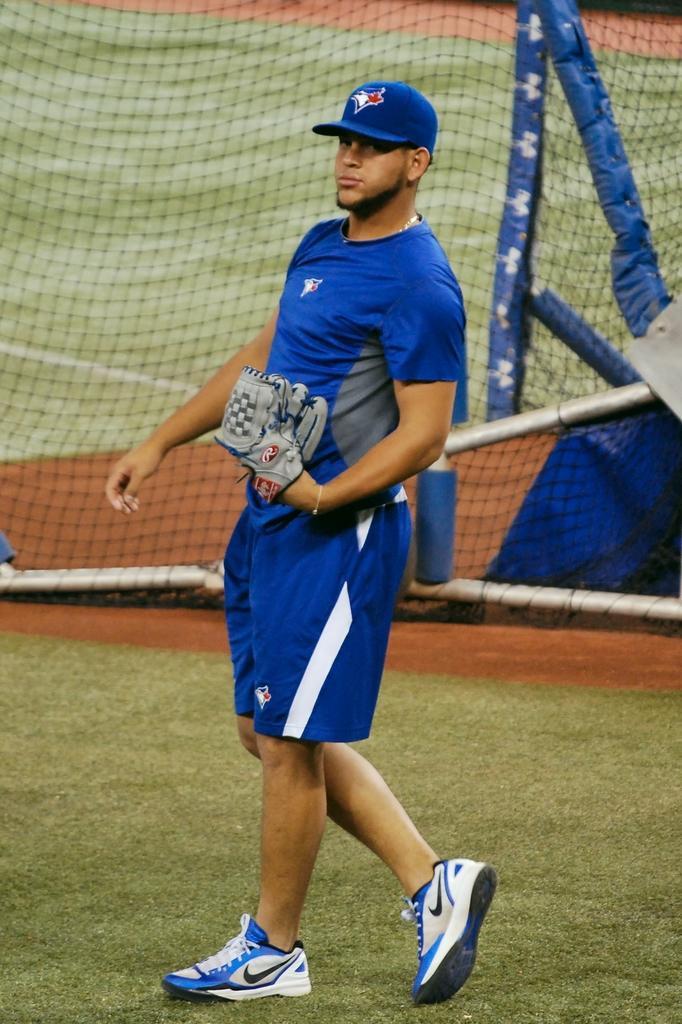How would you summarize this image in a sentence or two? Here in this picture we can see a person walking on the ground, which is fully covered with grass and he is holding gloves and wearing cap and behind him we can see a net present. 